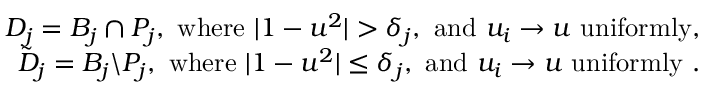<formula> <loc_0><loc_0><loc_500><loc_500>\begin{array} { r l r } & { D _ { j } = B _ { j } \cap P _ { j } , w h e r e | 1 - u ^ { 2 } | > \delta _ { j } , a n d u _ { i } \rightarrow u u n i f o r m l y , } \\ & { \tilde { D } _ { j } = B _ { j } \ P _ { j } , w h e r e | 1 - u ^ { 2 } | \leq \delta _ { j } , a n d u _ { i } \rightarrow u u n i f o r m l y . } \end{array}</formula> 